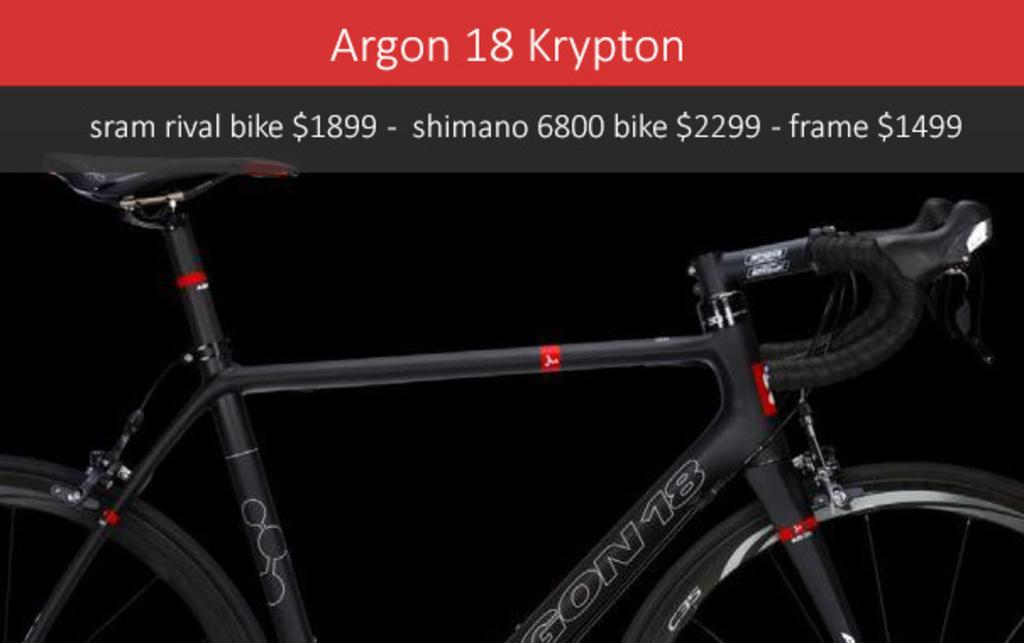What is the main object in the image? There is a bicycle in the image. What else can be seen at the top of the image? There is text at the top of the image. How many legs does the hat have in the image? There is no hat present in the image, so it is not possible to determine the number of legs it might have. 